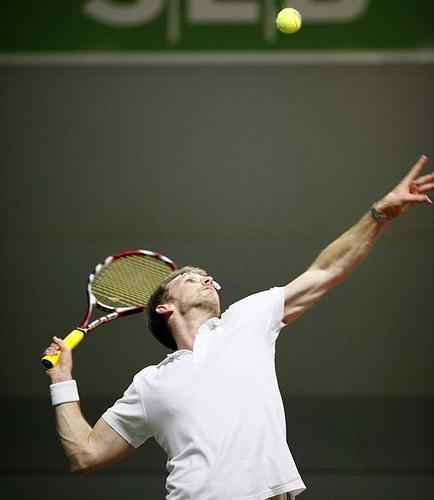How many tennis rackets are there?
Give a very brief answer. 1. 